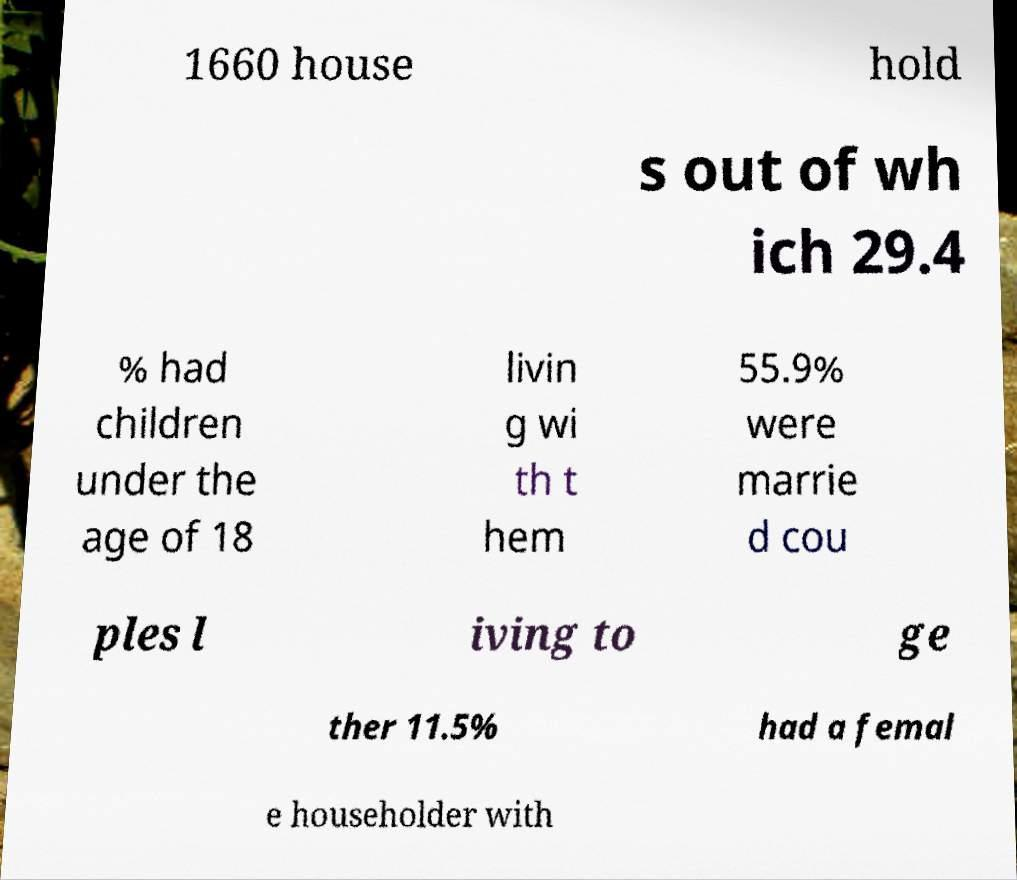There's text embedded in this image that I need extracted. Can you transcribe it verbatim? 1660 house hold s out of wh ich 29.4 % had children under the age of 18 livin g wi th t hem 55.9% were marrie d cou ples l iving to ge ther 11.5% had a femal e householder with 